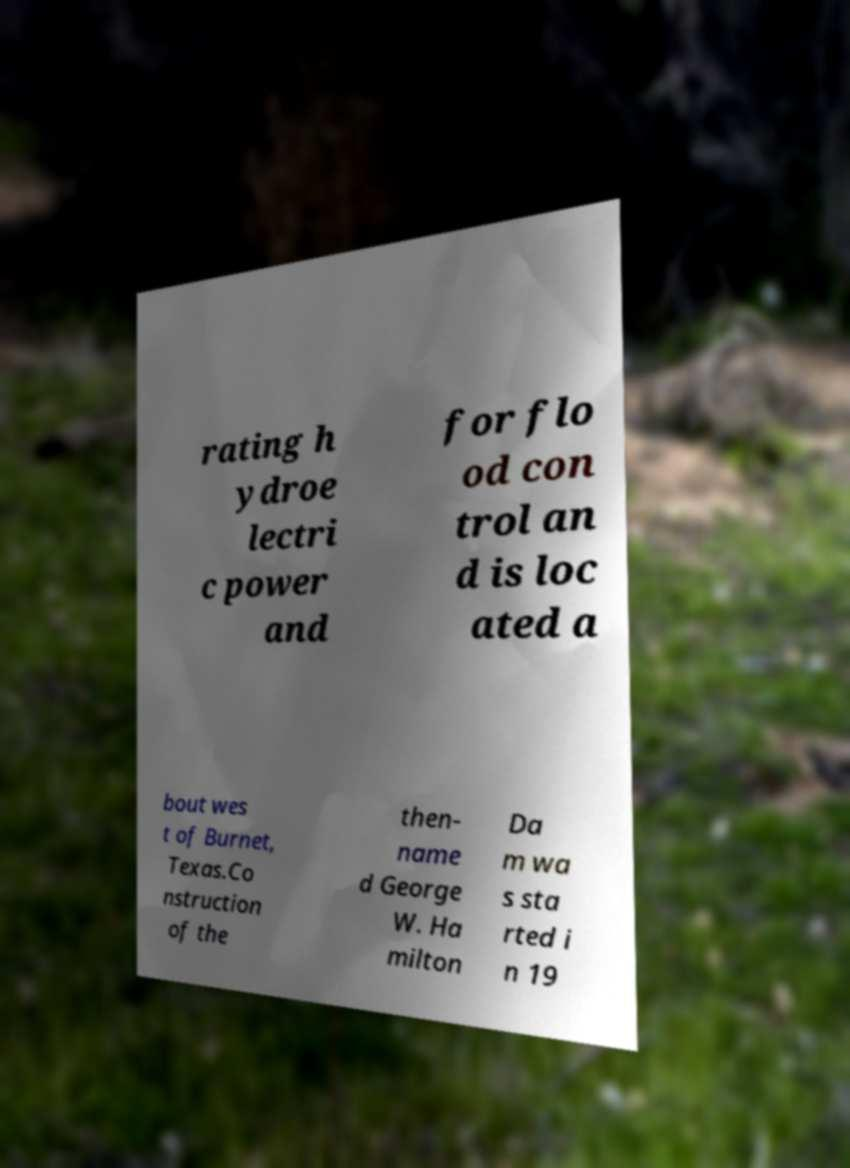Could you assist in decoding the text presented in this image and type it out clearly? rating h ydroe lectri c power and for flo od con trol an d is loc ated a bout wes t of Burnet, Texas.Co nstruction of the then- name d George W. Ha milton Da m wa s sta rted i n 19 